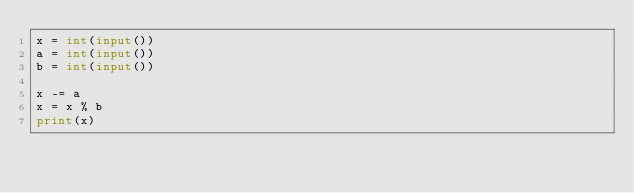<code> <loc_0><loc_0><loc_500><loc_500><_Python_>x = int(input())
a = int(input())
b = int(input())

x -= a
x = x % b
print(x)
</code> 